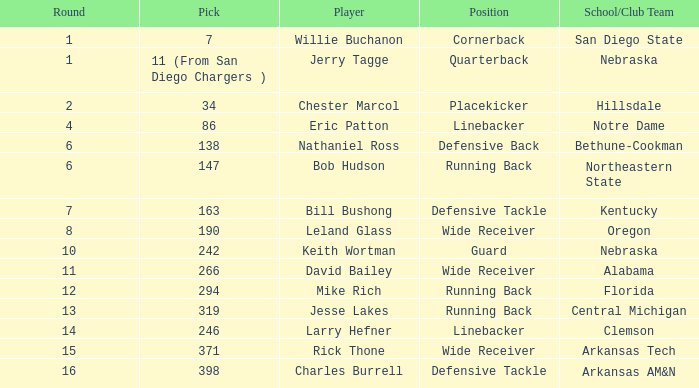Help me parse the entirety of this table. {'header': ['Round', 'Pick', 'Player', 'Position', 'School/Club Team'], 'rows': [['1', '7', 'Willie Buchanon', 'Cornerback', 'San Diego State'], ['1', '11 (From San Diego Chargers )', 'Jerry Tagge', 'Quarterback', 'Nebraska'], ['2', '34', 'Chester Marcol', 'Placekicker', 'Hillsdale'], ['4', '86', 'Eric Patton', 'Linebacker', 'Notre Dame'], ['6', '138', 'Nathaniel Ross', 'Defensive Back', 'Bethune-Cookman'], ['6', '147', 'Bob Hudson', 'Running Back', 'Northeastern State'], ['7', '163', 'Bill Bushong', 'Defensive Tackle', 'Kentucky'], ['8', '190', 'Leland Glass', 'Wide Receiver', 'Oregon'], ['10', '242', 'Keith Wortman', 'Guard', 'Nebraska'], ['11', '266', 'David Bailey', 'Wide Receiver', 'Alabama'], ['12', '294', 'Mike Rich', 'Running Back', 'Florida'], ['13', '319', 'Jesse Lakes', 'Running Back', 'Central Michigan'], ['14', '246', 'Larry Hefner', 'Linebacker', 'Clemson'], ['15', '371', 'Rick Thone', 'Wide Receiver', 'Arkansas Tech'], ['16', '398', 'Charles Burrell', 'Defensive Tackle', 'Arkansas AM&N']]} Which choice has a school/club team that is kentucky? 163.0. 